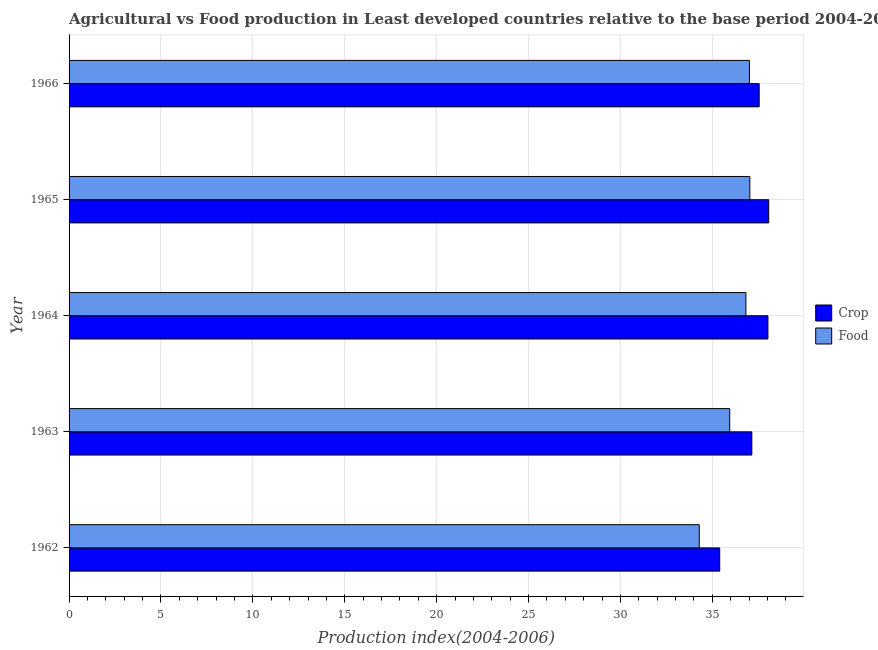How many different coloured bars are there?
Provide a short and direct response. 2. How many groups of bars are there?
Your response must be concise. 5. Are the number of bars per tick equal to the number of legend labels?
Your answer should be compact. Yes. Are the number of bars on each tick of the Y-axis equal?
Keep it short and to the point. Yes. How many bars are there on the 1st tick from the top?
Provide a short and direct response. 2. What is the label of the 5th group of bars from the top?
Keep it short and to the point. 1962. What is the crop production index in 1962?
Offer a terse response. 35.4. Across all years, what is the maximum food production index?
Your answer should be very brief. 37.04. Across all years, what is the minimum food production index?
Offer a very short reply. 34.29. In which year was the food production index maximum?
Offer a very short reply. 1965. What is the total food production index in the graph?
Your response must be concise. 181.12. What is the difference between the food production index in 1962 and that in 1965?
Give a very brief answer. -2.75. What is the difference between the food production index in 1963 and the crop production index in 1964?
Keep it short and to the point. -2.08. What is the average food production index per year?
Provide a succinct answer. 36.22. In the year 1966, what is the difference between the crop production index and food production index?
Your answer should be compact. 0.53. What is the ratio of the food production index in 1962 to that in 1965?
Make the answer very short. 0.93. Is the difference between the crop production index in 1962 and 1966 greater than the difference between the food production index in 1962 and 1966?
Offer a very short reply. Yes. What is the difference between the highest and the second highest crop production index?
Keep it short and to the point. 0.04. What is the difference between the highest and the lowest food production index?
Offer a very short reply. 2.75. Is the sum of the crop production index in 1963 and 1964 greater than the maximum food production index across all years?
Your answer should be compact. Yes. What does the 2nd bar from the top in 1963 represents?
Provide a succinct answer. Crop. What does the 2nd bar from the bottom in 1965 represents?
Offer a very short reply. Food. Are all the bars in the graph horizontal?
Provide a short and direct response. Yes. How many years are there in the graph?
Provide a succinct answer. 5. What is the difference between two consecutive major ticks on the X-axis?
Your answer should be compact. 5. Are the values on the major ticks of X-axis written in scientific E-notation?
Ensure brevity in your answer.  No. How many legend labels are there?
Provide a short and direct response. 2. How are the legend labels stacked?
Your response must be concise. Vertical. What is the title of the graph?
Ensure brevity in your answer.  Agricultural vs Food production in Least developed countries relative to the base period 2004-2006. What is the label or title of the X-axis?
Your answer should be compact. Production index(2004-2006). What is the Production index(2004-2006) in Crop in 1962?
Make the answer very short. 35.4. What is the Production index(2004-2006) in Food in 1962?
Your answer should be very brief. 34.29. What is the Production index(2004-2006) of Crop in 1963?
Ensure brevity in your answer.  37.15. What is the Production index(2004-2006) of Food in 1963?
Your answer should be compact. 35.95. What is the Production index(2004-2006) of Crop in 1964?
Keep it short and to the point. 38.02. What is the Production index(2004-2006) of Food in 1964?
Provide a short and direct response. 36.83. What is the Production index(2004-2006) of Crop in 1965?
Your response must be concise. 38.07. What is the Production index(2004-2006) in Food in 1965?
Your answer should be compact. 37.04. What is the Production index(2004-2006) in Crop in 1966?
Keep it short and to the point. 37.55. What is the Production index(2004-2006) in Food in 1966?
Offer a terse response. 37.02. Across all years, what is the maximum Production index(2004-2006) of Crop?
Your answer should be very brief. 38.07. Across all years, what is the maximum Production index(2004-2006) in Food?
Your answer should be very brief. 37.04. Across all years, what is the minimum Production index(2004-2006) in Crop?
Ensure brevity in your answer.  35.4. Across all years, what is the minimum Production index(2004-2006) of Food?
Keep it short and to the point. 34.29. What is the total Production index(2004-2006) in Crop in the graph?
Your answer should be very brief. 186.19. What is the total Production index(2004-2006) of Food in the graph?
Your answer should be very brief. 181.12. What is the difference between the Production index(2004-2006) in Crop in 1962 and that in 1963?
Offer a very short reply. -1.75. What is the difference between the Production index(2004-2006) of Food in 1962 and that in 1963?
Make the answer very short. -1.66. What is the difference between the Production index(2004-2006) of Crop in 1962 and that in 1964?
Ensure brevity in your answer.  -2.62. What is the difference between the Production index(2004-2006) of Food in 1962 and that in 1964?
Ensure brevity in your answer.  -2.54. What is the difference between the Production index(2004-2006) of Crop in 1962 and that in 1965?
Make the answer very short. -2.67. What is the difference between the Production index(2004-2006) in Food in 1962 and that in 1965?
Give a very brief answer. -2.75. What is the difference between the Production index(2004-2006) in Crop in 1962 and that in 1966?
Offer a terse response. -2.15. What is the difference between the Production index(2004-2006) of Food in 1962 and that in 1966?
Offer a terse response. -2.73. What is the difference between the Production index(2004-2006) of Crop in 1963 and that in 1964?
Ensure brevity in your answer.  -0.88. What is the difference between the Production index(2004-2006) in Food in 1963 and that in 1964?
Offer a very short reply. -0.88. What is the difference between the Production index(2004-2006) of Crop in 1963 and that in 1965?
Offer a terse response. -0.92. What is the difference between the Production index(2004-2006) of Food in 1963 and that in 1965?
Offer a terse response. -1.09. What is the difference between the Production index(2004-2006) in Crop in 1963 and that in 1966?
Give a very brief answer. -0.4. What is the difference between the Production index(2004-2006) of Food in 1963 and that in 1966?
Your answer should be very brief. -1.07. What is the difference between the Production index(2004-2006) of Crop in 1964 and that in 1965?
Keep it short and to the point. -0.04. What is the difference between the Production index(2004-2006) in Food in 1964 and that in 1965?
Provide a short and direct response. -0.21. What is the difference between the Production index(2004-2006) in Crop in 1964 and that in 1966?
Give a very brief answer. 0.48. What is the difference between the Production index(2004-2006) in Food in 1964 and that in 1966?
Provide a short and direct response. -0.19. What is the difference between the Production index(2004-2006) of Crop in 1965 and that in 1966?
Your answer should be compact. 0.52. What is the difference between the Production index(2004-2006) in Food in 1965 and that in 1966?
Your answer should be compact. 0.02. What is the difference between the Production index(2004-2006) of Crop in 1962 and the Production index(2004-2006) of Food in 1963?
Provide a short and direct response. -0.54. What is the difference between the Production index(2004-2006) of Crop in 1962 and the Production index(2004-2006) of Food in 1964?
Provide a succinct answer. -1.42. What is the difference between the Production index(2004-2006) of Crop in 1962 and the Production index(2004-2006) of Food in 1965?
Provide a short and direct response. -1.64. What is the difference between the Production index(2004-2006) in Crop in 1962 and the Production index(2004-2006) in Food in 1966?
Make the answer very short. -1.62. What is the difference between the Production index(2004-2006) of Crop in 1963 and the Production index(2004-2006) of Food in 1964?
Offer a terse response. 0.32. What is the difference between the Production index(2004-2006) in Crop in 1963 and the Production index(2004-2006) in Food in 1965?
Provide a succinct answer. 0.11. What is the difference between the Production index(2004-2006) of Crop in 1963 and the Production index(2004-2006) of Food in 1966?
Make the answer very short. 0.13. What is the difference between the Production index(2004-2006) in Crop in 1964 and the Production index(2004-2006) in Food in 1965?
Provide a short and direct response. 0.98. What is the difference between the Production index(2004-2006) of Crop in 1965 and the Production index(2004-2006) of Food in 1966?
Your answer should be very brief. 1.05. What is the average Production index(2004-2006) of Crop per year?
Your response must be concise. 37.24. What is the average Production index(2004-2006) in Food per year?
Offer a terse response. 36.22. In the year 1962, what is the difference between the Production index(2004-2006) in Crop and Production index(2004-2006) in Food?
Your response must be concise. 1.11. In the year 1963, what is the difference between the Production index(2004-2006) of Crop and Production index(2004-2006) of Food?
Your answer should be compact. 1.2. In the year 1964, what is the difference between the Production index(2004-2006) of Crop and Production index(2004-2006) of Food?
Provide a short and direct response. 1.2. In the year 1965, what is the difference between the Production index(2004-2006) in Crop and Production index(2004-2006) in Food?
Your response must be concise. 1.03. In the year 1966, what is the difference between the Production index(2004-2006) in Crop and Production index(2004-2006) in Food?
Your answer should be compact. 0.53. What is the ratio of the Production index(2004-2006) in Crop in 1962 to that in 1963?
Your answer should be very brief. 0.95. What is the ratio of the Production index(2004-2006) in Food in 1962 to that in 1963?
Give a very brief answer. 0.95. What is the ratio of the Production index(2004-2006) in Food in 1962 to that in 1964?
Keep it short and to the point. 0.93. What is the ratio of the Production index(2004-2006) in Food in 1962 to that in 1965?
Keep it short and to the point. 0.93. What is the ratio of the Production index(2004-2006) in Crop in 1962 to that in 1966?
Offer a very short reply. 0.94. What is the ratio of the Production index(2004-2006) of Food in 1962 to that in 1966?
Give a very brief answer. 0.93. What is the ratio of the Production index(2004-2006) of Food in 1963 to that in 1964?
Your answer should be compact. 0.98. What is the ratio of the Production index(2004-2006) of Crop in 1963 to that in 1965?
Provide a succinct answer. 0.98. What is the ratio of the Production index(2004-2006) of Food in 1963 to that in 1965?
Offer a very short reply. 0.97. What is the ratio of the Production index(2004-2006) of Crop in 1963 to that in 1966?
Provide a short and direct response. 0.99. What is the ratio of the Production index(2004-2006) in Crop in 1964 to that in 1965?
Provide a succinct answer. 1. What is the ratio of the Production index(2004-2006) of Food in 1964 to that in 1965?
Make the answer very short. 0.99. What is the ratio of the Production index(2004-2006) of Crop in 1964 to that in 1966?
Provide a short and direct response. 1.01. What is the ratio of the Production index(2004-2006) of Food in 1964 to that in 1966?
Your answer should be compact. 0.99. What is the ratio of the Production index(2004-2006) in Crop in 1965 to that in 1966?
Provide a succinct answer. 1.01. What is the ratio of the Production index(2004-2006) of Food in 1965 to that in 1966?
Your answer should be compact. 1. What is the difference between the highest and the second highest Production index(2004-2006) of Crop?
Offer a very short reply. 0.04. What is the difference between the highest and the second highest Production index(2004-2006) of Food?
Provide a short and direct response. 0.02. What is the difference between the highest and the lowest Production index(2004-2006) in Crop?
Your answer should be compact. 2.67. What is the difference between the highest and the lowest Production index(2004-2006) in Food?
Give a very brief answer. 2.75. 